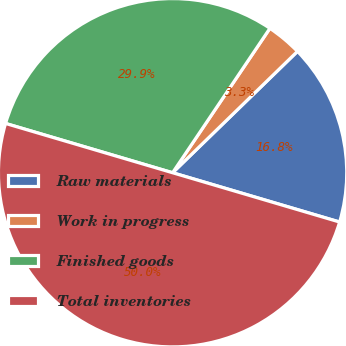Convert chart to OTSL. <chart><loc_0><loc_0><loc_500><loc_500><pie_chart><fcel>Raw materials<fcel>Work in progress<fcel>Finished goods<fcel>Total inventories<nl><fcel>16.84%<fcel>3.29%<fcel>29.87%<fcel>50.0%<nl></chart> 